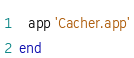Convert code to text. <code><loc_0><loc_0><loc_500><loc_500><_Ruby_>  app 'Cacher.app'
end
</code> 